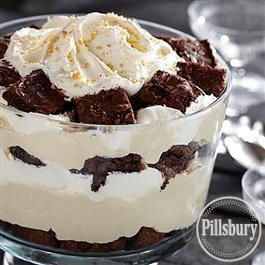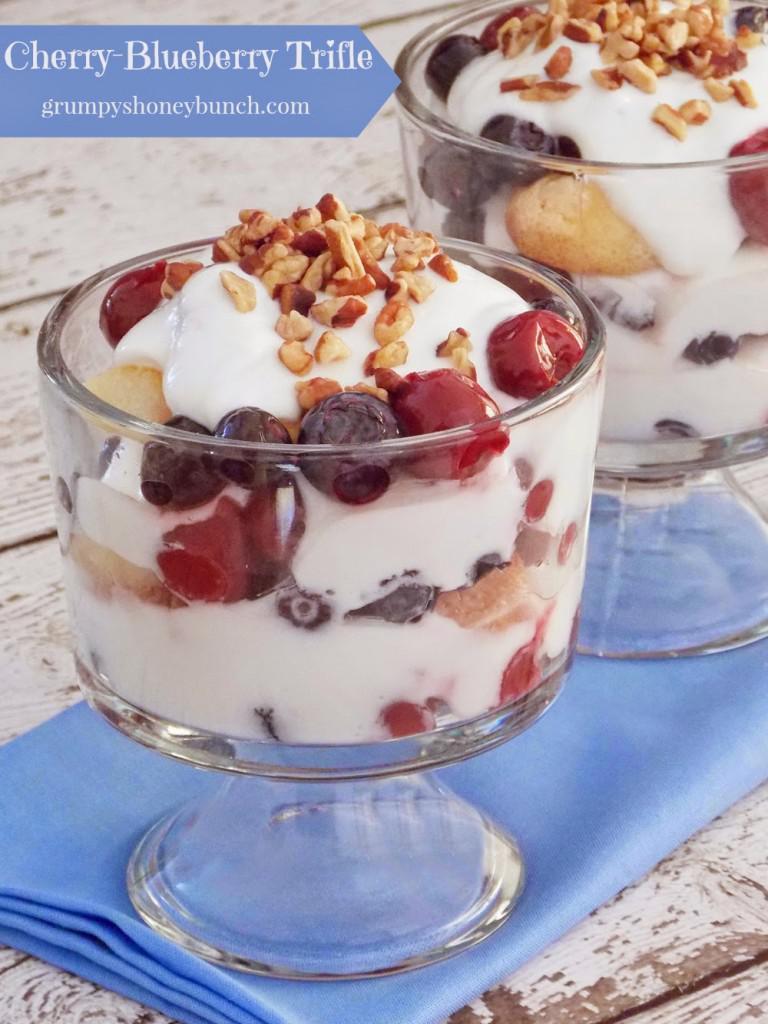The first image is the image on the left, the second image is the image on the right. Evaluate the accuracy of this statement regarding the images: "The right image shows exactly two virtually identical trifle desserts.". Is it true? Answer yes or no. Yes. The first image is the image on the left, the second image is the image on the right. Examine the images to the left and right. Is the description "There is at least one cherry with a stem in the image on the right." accurate? Answer yes or no. No. 